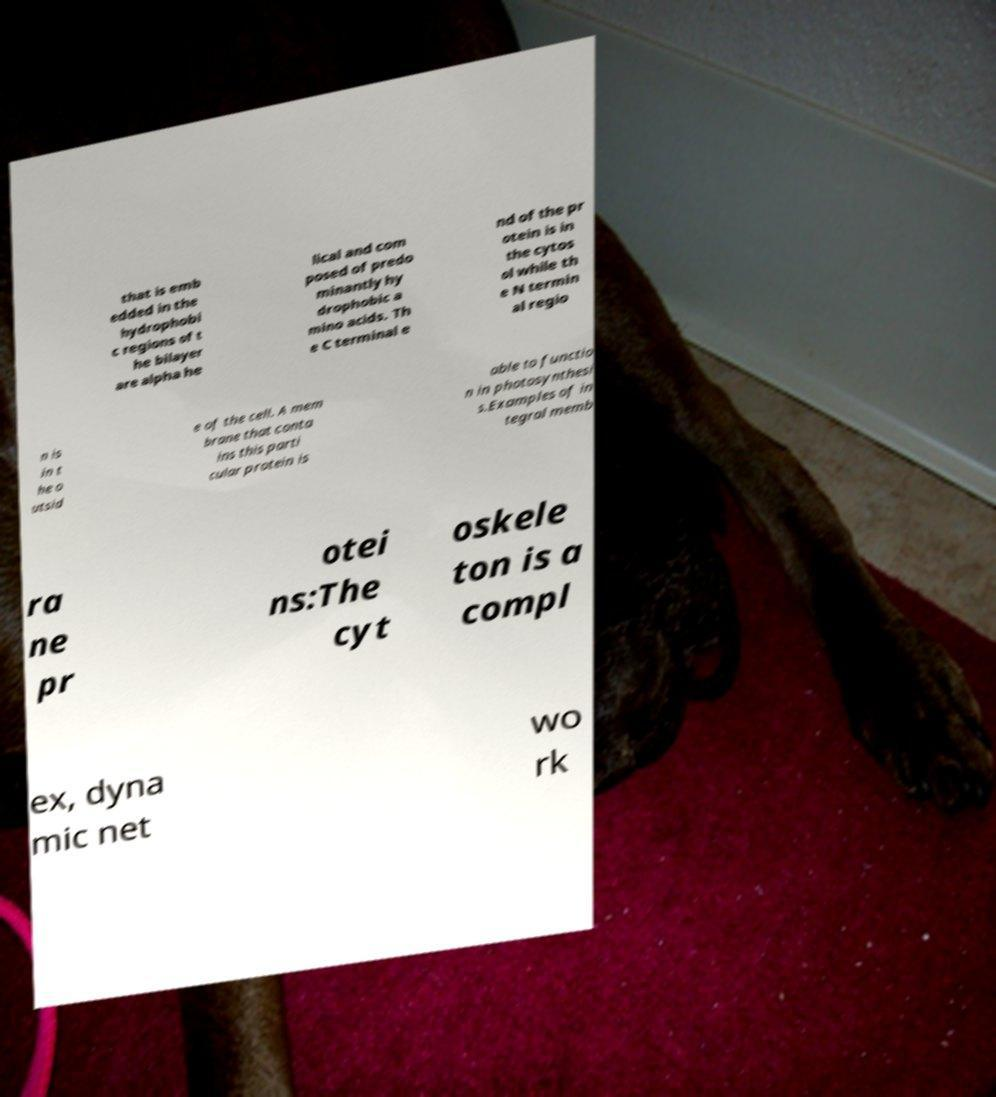What messages or text are displayed in this image? I need them in a readable, typed format. that is emb edded in the hydrophobi c regions of t he bilayer are alpha he lical and com posed of predo minantly hy drophobic a mino acids. Th e C terminal e nd of the pr otein is in the cytos ol while th e N termin al regio n is in t he o utsid e of the cell. A mem brane that conta ins this parti cular protein is able to functio n in photosynthesi s.Examples of in tegral memb ra ne pr otei ns:The cyt oskele ton is a compl ex, dyna mic net wo rk 